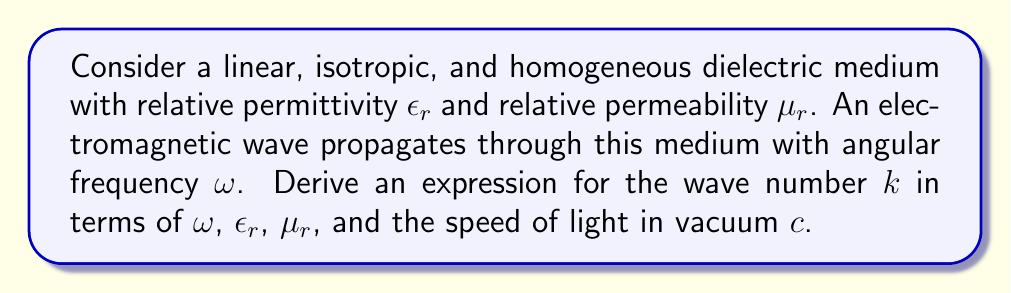Can you solve this math problem? 1) Start with Maxwell's equations for a linear, isotropic, and homogeneous medium:

   $$\nabla \cdot \mathbf{E} = 0$$
   $$\nabla \cdot \mathbf{B} = 0$$
   $$\nabla \times \mathbf{E} = -\frac{\partial \mathbf{B}}{\partial t}$$
   $$\nabla \times \mathbf{B} = \mu_0\epsilon_0\epsilon_r\mu_r\frac{\partial \mathbf{E}}{\partial t}$$

2) Assume a plane wave solution of the form:
   
   $$\mathbf{E} = \mathbf{E}_0 e^{i(\mathbf{k} \cdot \mathbf{r} - \omega t)}$$
   $$\mathbf{B} = \mathbf{B}_0 e^{i(\mathbf{k} \cdot \mathbf{r} - \omega t)}$$

3) Substitute these into the curl equations:

   $$i\mathbf{k} \times \mathbf{E}_0 = i\omega \mathbf{B}_0$$
   $$i\mathbf{k} \times \mathbf{B}_0 = -i\omega \mu_0\epsilon_0\epsilon_r\mu_r\mathbf{E}_0$$

4) Take the curl of the first equation:

   $$i\mathbf{k} \times (i\mathbf{k} \times \mathbf{E}_0) = i\omega (i\mathbf{k} \times \mathbf{B}_0)$$

5) Use the vector identity $\mathbf{a} \times (\mathbf{b} \times \mathbf{c}) = (\mathbf{a} \cdot \mathbf{c})\mathbf{b} - (\mathbf{a} \cdot \mathbf{b})\mathbf{c}$:

   $$-k^2\mathbf{E}_0 + \mathbf{k}(\mathbf{k} \cdot \mathbf{E}_0) = \omega \mu_0\epsilon_0\epsilon_r\mu_r\omega \mathbf{E}_0$$

6) Since $\nabla \cdot \mathbf{E} = 0$, we have $\mathbf{k} \cdot \mathbf{E}_0 = 0$, so:

   $$-k^2\mathbf{E}_0 = -\omega^2 \mu_0\epsilon_0\epsilon_r\mu_r\mathbf{E}_0$$

7) This gives us:

   $$k^2 = \omega^2 \mu_0\epsilon_0\epsilon_r\mu_r$$

8) Recall that $c = \frac{1}{\sqrt{\mu_0\epsilon_0}}$, so:

   $$k^2 = \frac{\omega^2}{c^2}\epsilon_r\mu_r$$

9) Taking the square root of both sides:

   $$k = \frac{\omega}{c}\sqrt{\epsilon_r\mu_r}$$
Answer: $k = \frac{\omega}{c}\sqrt{\epsilon_r\mu_r}$ 